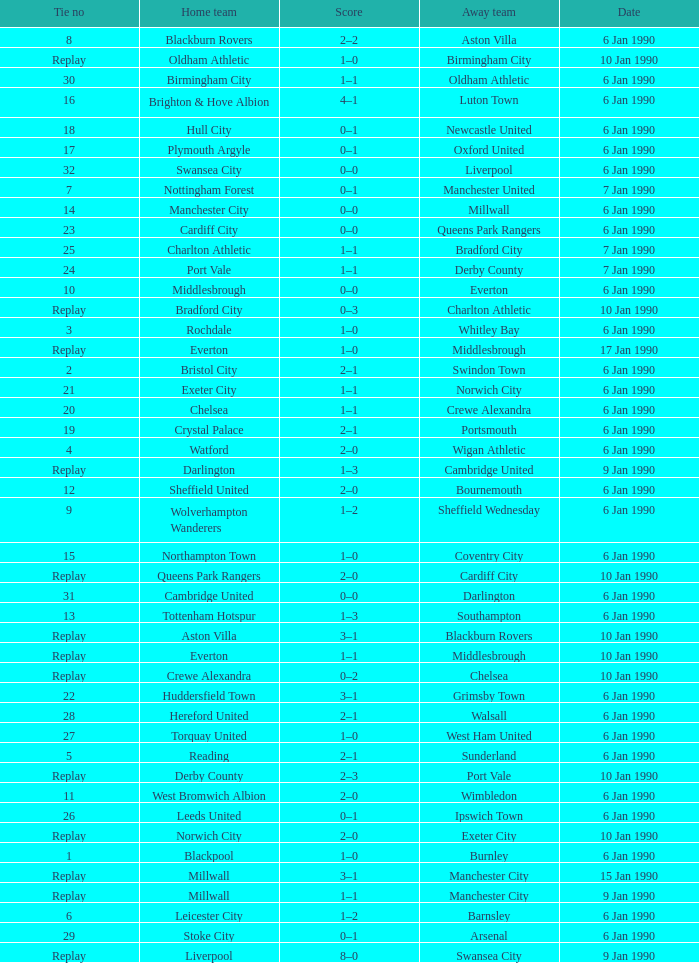What is the score of the game against away team exeter city on 10 jan 1990? 2–0. 